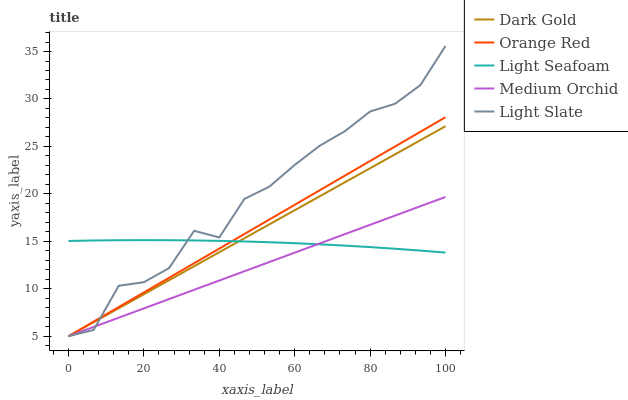Does Medium Orchid have the minimum area under the curve?
Answer yes or no. Yes. Does Light Slate have the maximum area under the curve?
Answer yes or no. Yes. Does Light Seafoam have the minimum area under the curve?
Answer yes or no. No. Does Light Seafoam have the maximum area under the curve?
Answer yes or no. No. Is Dark Gold the smoothest?
Answer yes or no. Yes. Is Light Slate the roughest?
Answer yes or no. Yes. Is Medium Orchid the smoothest?
Answer yes or no. No. Is Medium Orchid the roughest?
Answer yes or no. No. Does Light Seafoam have the lowest value?
Answer yes or no. No. Does Light Slate have the highest value?
Answer yes or no. Yes. Does Medium Orchid have the highest value?
Answer yes or no. No. Does Light Seafoam intersect Medium Orchid?
Answer yes or no. Yes. Is Light Seafoam less than Medium Orchid?
Answer yes or no. No. Is Light Seafoam greater than Medium Orchid?
Answer yes or no. No. 